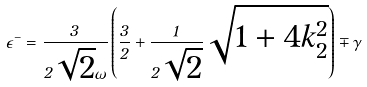<formula> <loc_0><loc_0><loc_500><loc_500>\epsilon ^ { - } = \frac { 3 } { 2 \sqrt { 2 } \omega } \left ( \frac { 3 } { 2 } + \frac { 1 } { 2 \sqrt { 2 } } \sqrt { 1 + 4 k ^ { 2 } _ { 2 } } \right ) \mp \gamma</formula> 